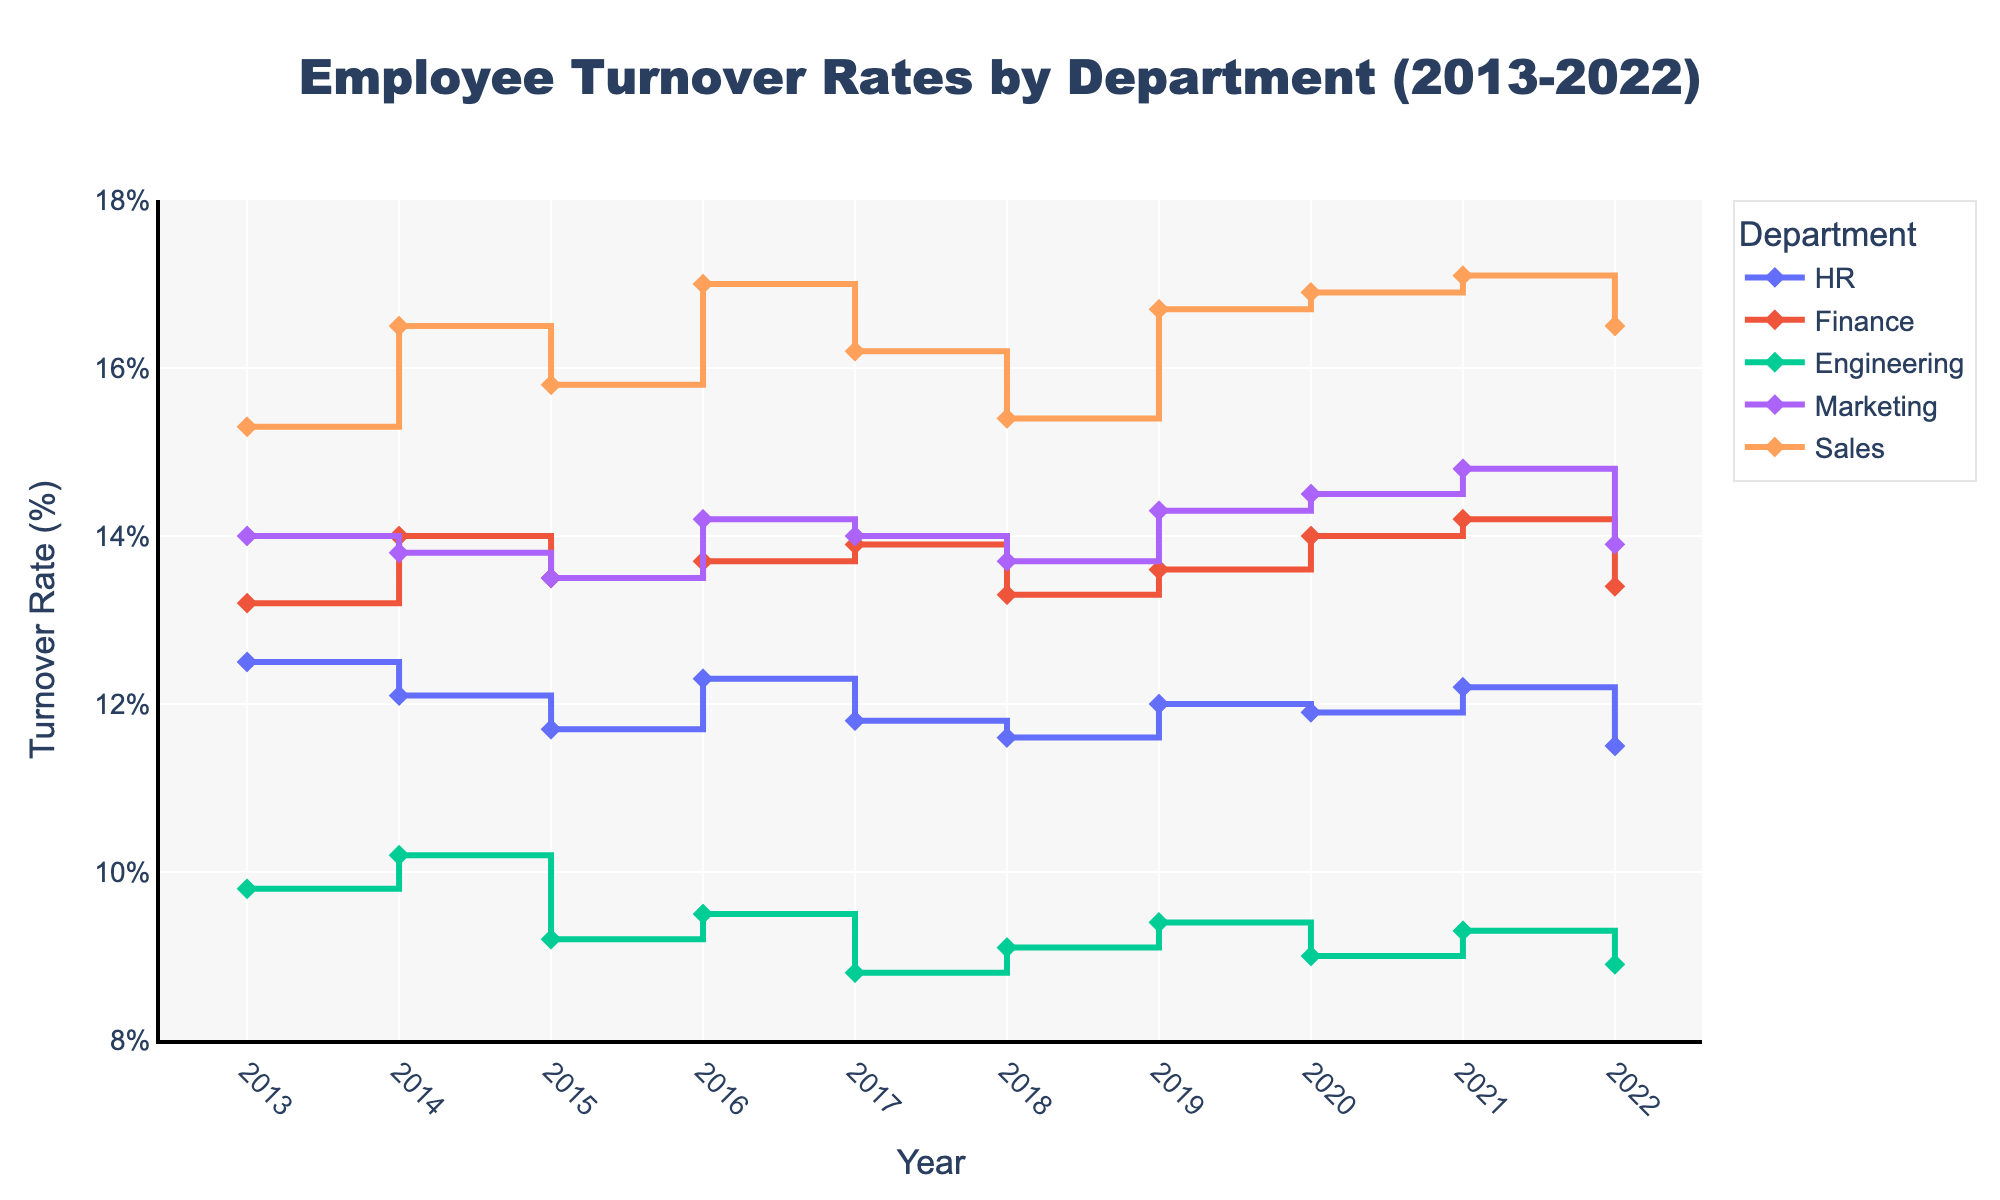What is the title of the figure? The title of the figure is centered at the top and reads "Employee Turnover Rates by Department (2013-2022)".
Answer: Employee Turnover Rates by Department (2013-2022) Which department had the lowest turnover rate in 2022? By examining the endpoints of each department's line, the lowest turnover rate in 2022 is associated with the Engineering department, which ends at 8.9%.
Answer: Engineering How did the turnover rate for the Sales department change from 2013 to 2022? Observe the plots for the Sales department from 2013 to 2022. The turnover rate started at 15.3% in 2013 and ended at 16.5% in 2022. The difference is calculated by subtracting the initial value from the final value: 16.5% - 15.3% = 1.2%.
Answer: Increased by 1.2% Which year had the highest turnover rate for the Finance department? Trace the line for the Finance department and identify the peak value. The highest turnover rate for Finance occurred in 2014 and 2020, both with a rate of 14%.
Answer: 2014 and 2020 What is the average turnover rate for the Marketing department from 2018 to 2022? Extract the turnover rates for Marketing from 2018 to 2022: 13.7%, 14.3%, 14.5%, 14.8%, and 13.9%. Calculate their average: (13.7 + 14.3 + 14.5 + 14.8 + 13.9) / 5 = 14.24%.
Answer: 14.24% Compare the turnover rates between HR and Engineering departments in 2017. Which is higher, and by how much? Locate the turnover rates for HR and Engineering in 2017: HR is 11.8% and Engineering is 8.8%. Subtract Engineering's rate from HR's rate: 11.8% - 8.8% = 3.0%. HR's turnover rate is higher by 3.0%.
Answer: HR is higher by 3.0% Which department showed the most fluctuation in turnover rates from 2013 to 2022? Check the overall pattern of each department's line to see which one has the most up-and-down movements. The Sales department demonstrates the most fluctuations, with noticeable changes nearly every year.
Answer: Sales How many departments are represented in the figure? Count the number of unique colored lines that represent different departments. There are 5 departments in total.
Answer: 5 Identify the year and department with the smallest turnover rate over the entire period. Find the lowest point among all lines. The smallest turnover rate recorded is 8.8% in Engineering for the year 2017.
Answer: 2017, Engineering 